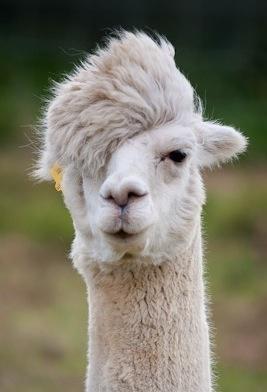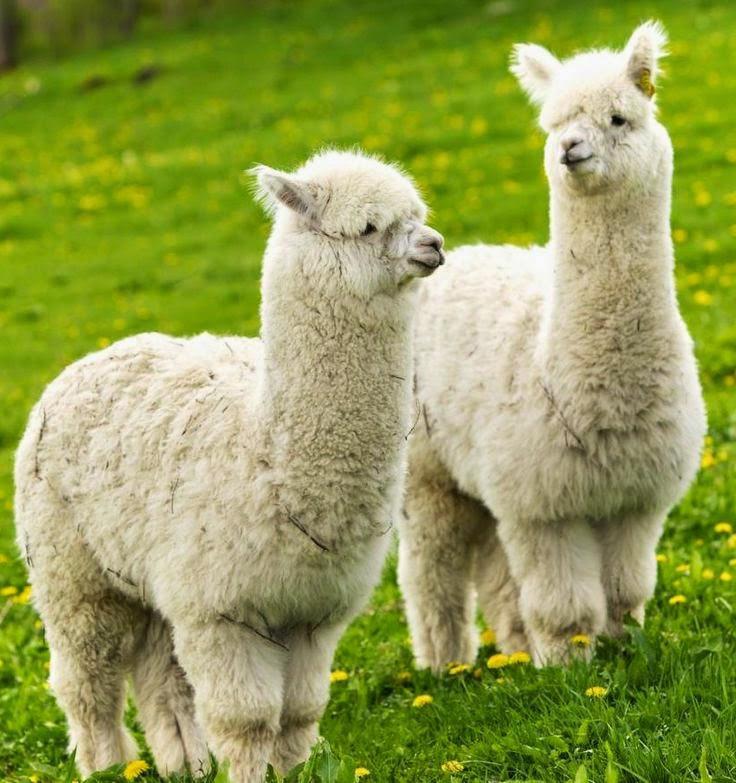The first image is the image on the left, the second image is the image on the right. Considering the images on both sides, is "The right image shows a single llama with its face in profile, and the left image shows a single llama with a round fuzzy head." valid? Answer yes or no. No. The first image is the image on the left, the second image is the image on the right. Examine the images to the left and right. Is the description "The animal on the left has distinct facial coloring that is black with white streaks, while the animal on the right is predominantly white." accurate? Answer yes or no. No. 